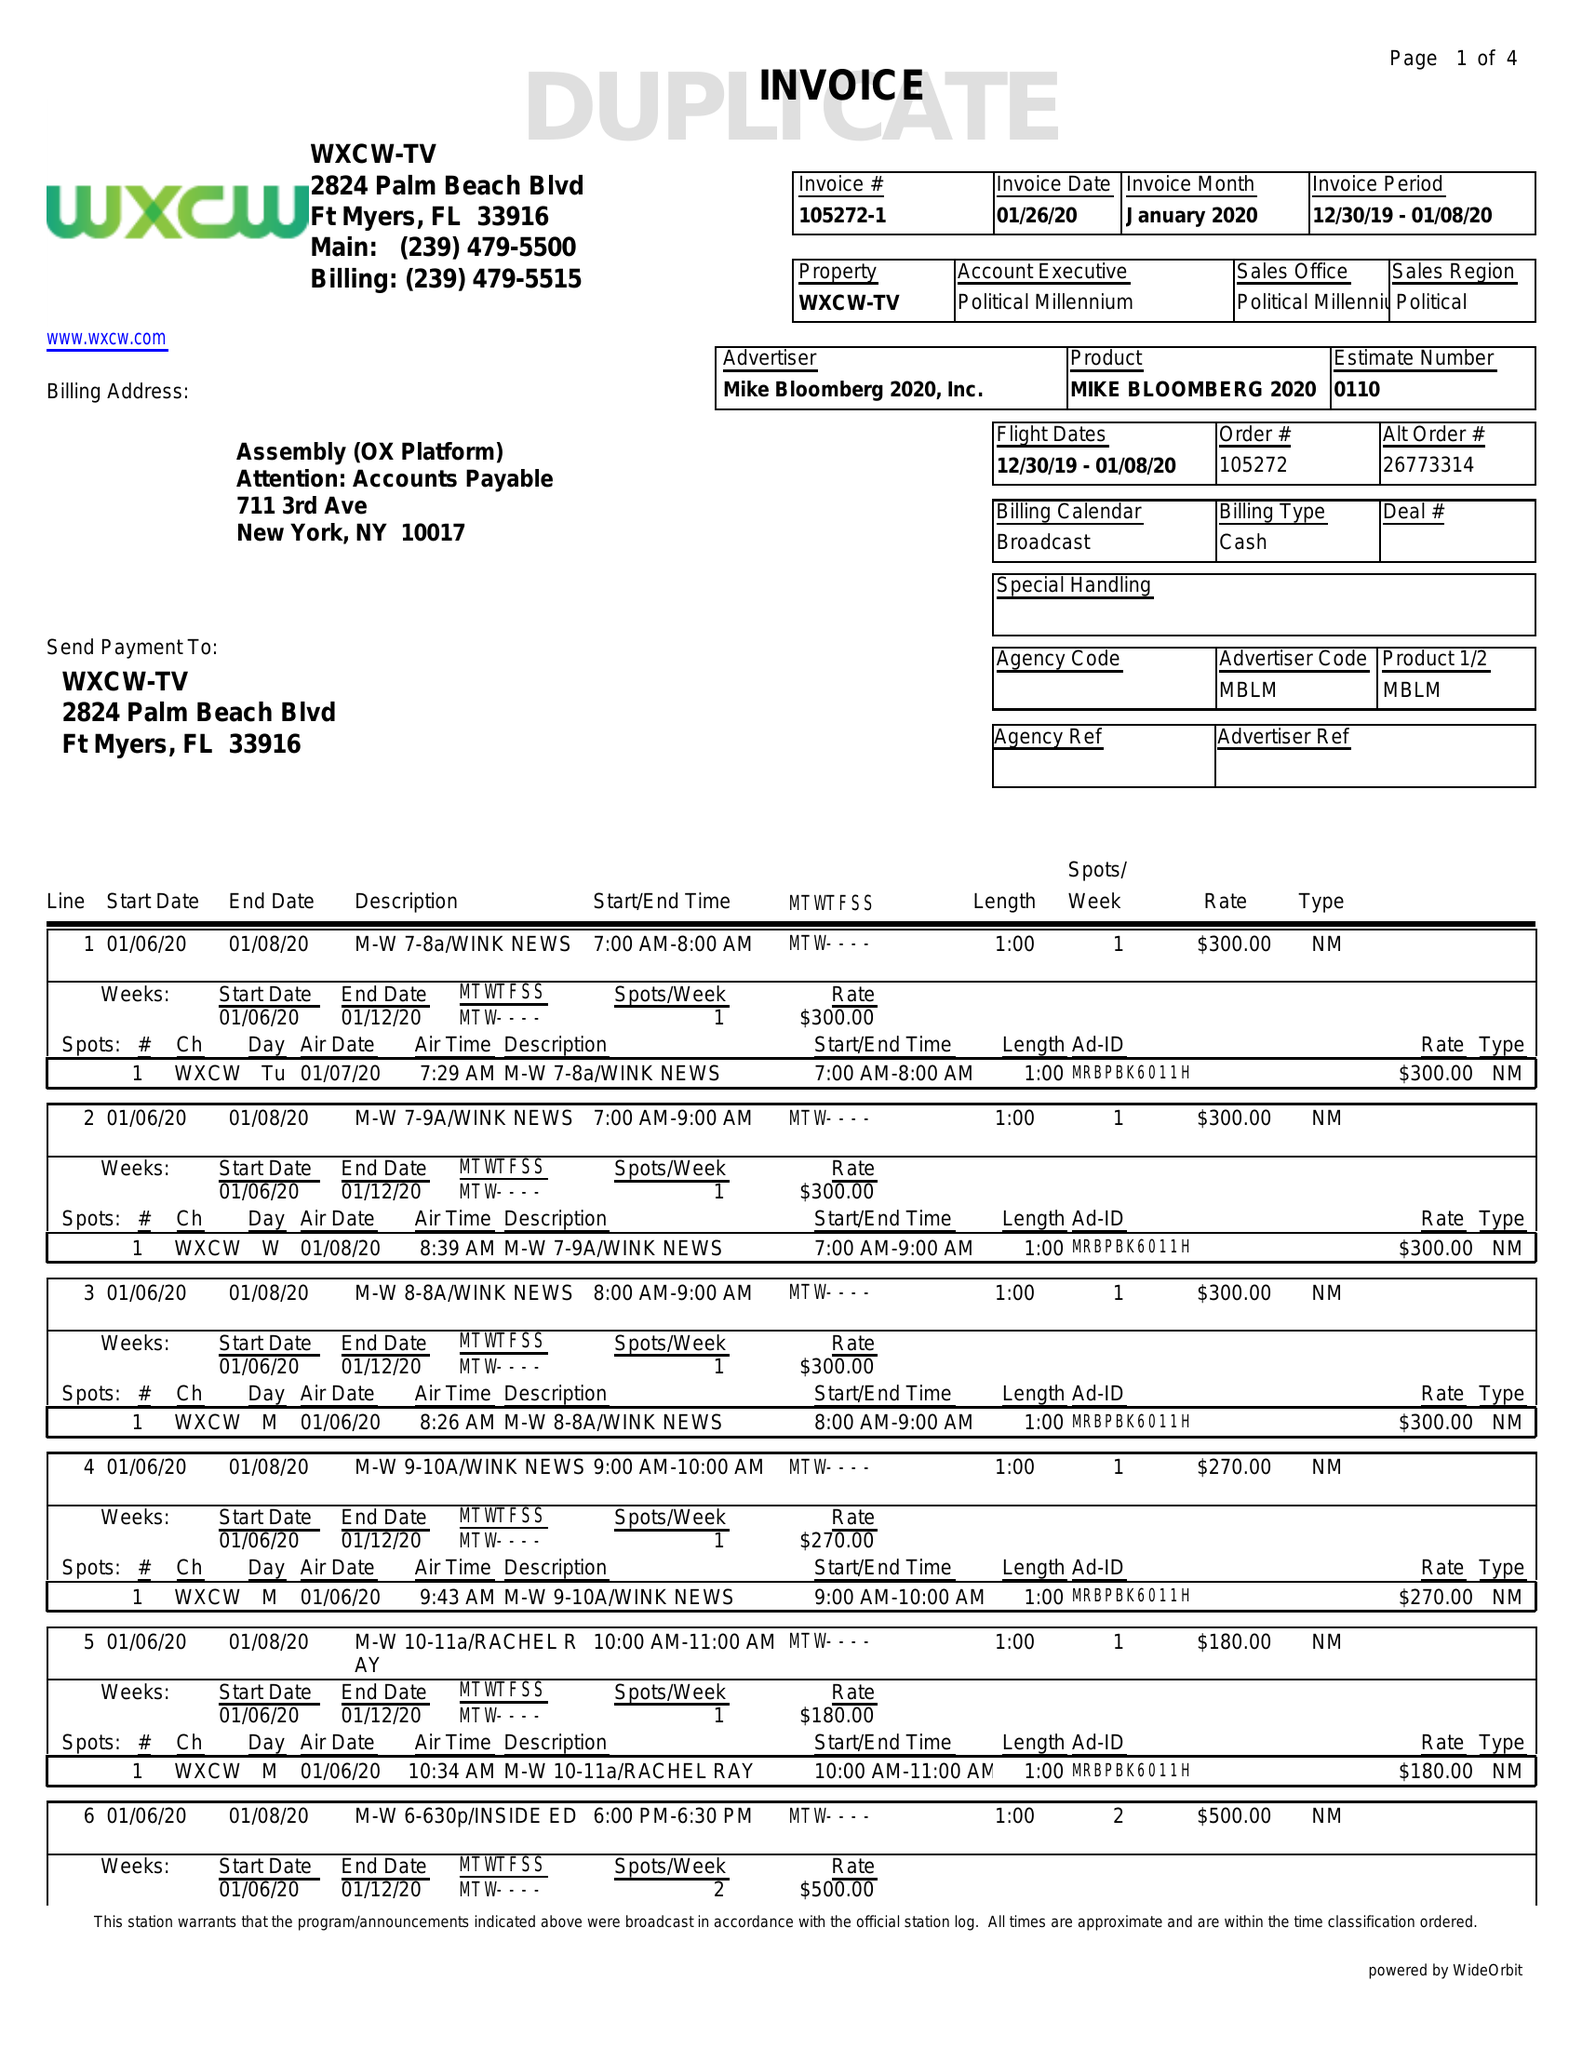What is the value for the contract_num?
Answer the question using a single word or phrase. 105272 